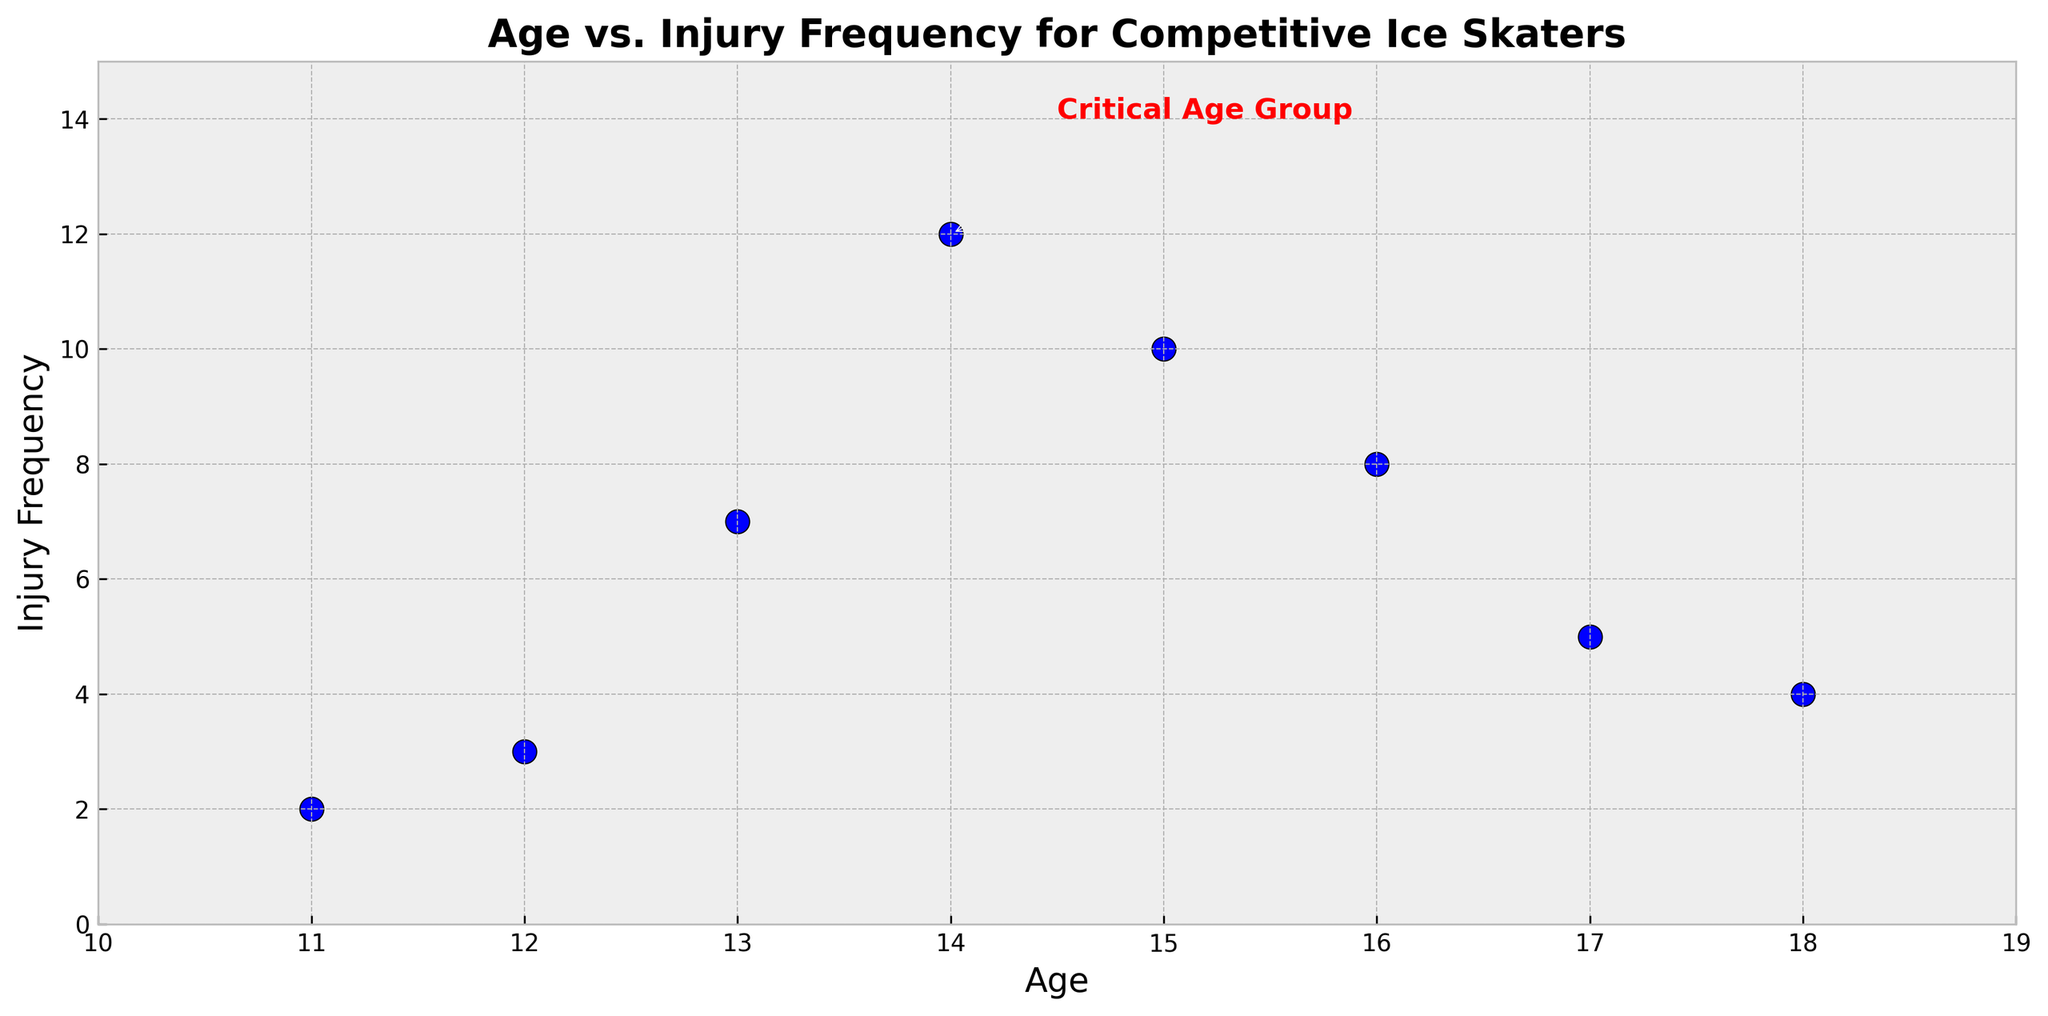What's the critical age group? The scatter plot has an annotation labeled "Critical Age Group" at the age of 14 with an injury frequency of 12. This is visually marked with an arrow pointing to the data point.
Answer: 14 What is the highest injury frequency, and at what age does it occur? The highest injury frequency on the scatter plot is 12, which can be found at the age of 14. This is easily visible as the highest point on the y-axis.
Answer: 12 at age 14 Compare the injury frequency at ages 15 and 18. Which one is higher? The scatter plot shows that at age 15, the injury frequency is 10, while at age 18, it is 4. Therefore, the injury frequency at age 15 is higher.
Answer: Age 15 What is the trend in injury frequency as age increases from 13 to 16? The scatter plot shows an initial increase from age 13 (7 injuries) to age 14 (12 injuries). Then it decreases to 10 injuries at age 15 and 8 injuries at age 16. This indicates a peak at age 14 followed by a decline.
Answer: Increases, peaks, then decreases Compare the injury frequency for ages 11 and 12. Are they close to each other? The scatter plot shows that the injury frequency at ages 11 and 12 is 2 and 3, respectively. The numbers are close when compared visually and numerically.
Answer: Yes Calculate the average injury frequency for ages 11 to 13. The injury frequencies for ages 11, 12, and 13 are 2, 3, and 7 respectively. Adding them gives 2 + 3 + 7 = 12. Dividing by the number of ages (3) results in an average of 12 / 3 = 4.
Answer: 4 Which age has the lowest injury frequency, and what value is it? The scatter plot shows that the age with the lowest injury frequency is 11, with a frequency of 2 injuries. This is the lowest point on the y-axis.
Answer: Age 11, 2 How does the injury frequency change from age 18 to age 17? The scatter plot shows that the injury frequency increases from 4 at age 18 to 5 at age 17. This indicates a slight increase.
Answer: Increases What is the range of injury frequencies shown in the scatter plot? The range of injury frequency can be calculated by subtracting the lowest frequency (2) from the highest frequency (12). This gives a range of 12 - 2 = 10.
Answer: 10 